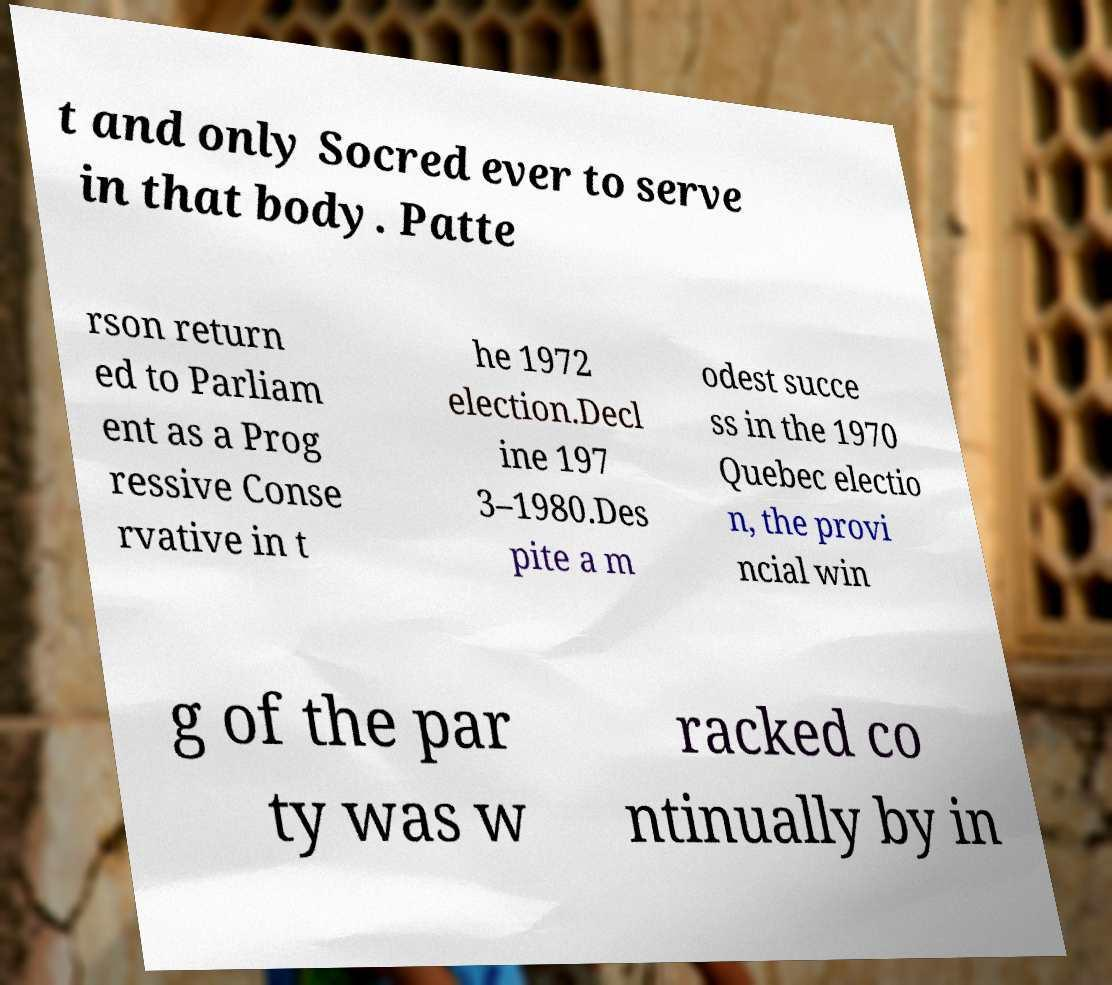Please identify and transcribe the text found in this image. t and only Socred ever to serve in that body. Patte rson return ed to Parliam ent as a Prog ressive Conse rvative in t he 1972 election.Decl ine 197 3–1980.Des pite a m odest succe ss in the 1970 Quebec electio n, the provi ncial win g of the par ty was w racked co ntinually by in 